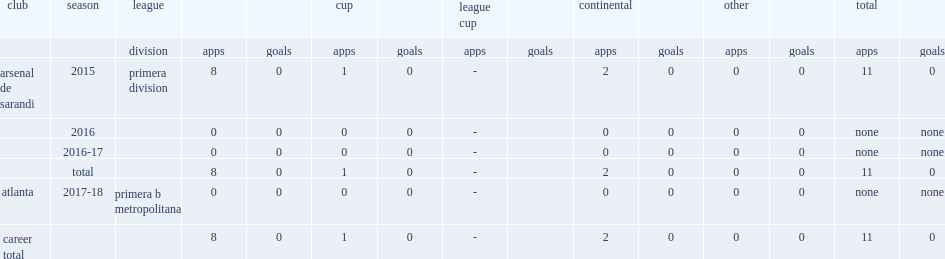Which club did ivan varga make his debut for in the 2015 primera division? Arsenal de sarandi. 